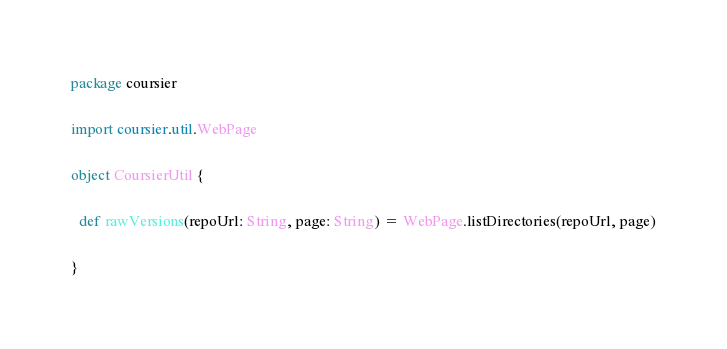<code> <loc_0><loc_0><loc_500><loc_500><_Scala_>package coursier

import coursier.util.WebPage

object CoursierUtil {

  def rawVersions(repoUrl: String, page: String) = WebPage.listDirectories(repoUrl, page)

}
</code> 